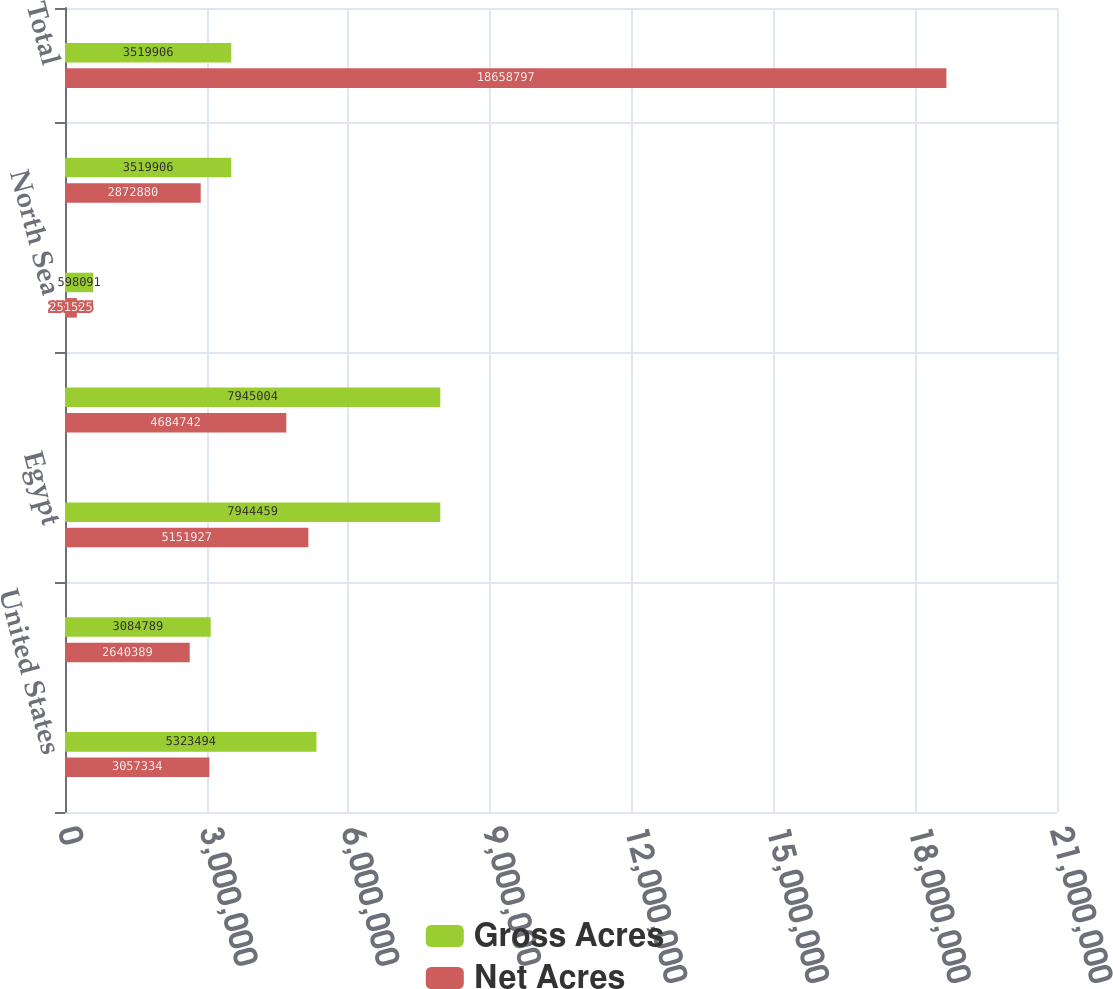<chart> <loc_0><loc_0><loc_500><loc_500><stacked_bar_chart><ecel><fcel>United States<fcel>Canada<fcel>Egypt<fcel>Australia<fcel>North Sea<fcel>Argentina<fcel>Total<nl><fcel>Gross Acres<fcel>5.32349e+06<fcel>3.08479e+06<fcel>7.94446e+06<fcel>7.945e+06<fcel>598091<fcel>3.51991e+06<fcel>3.51991e+06<nl><fcel>Net Acres<fcel>3.05733e+06<fcel>2.64039e+06<fcel>5.15193e+06<fcel>4.68474e+06<fcel>251525<fcel>2.87288e+06<fcel>1.86588e+07<nl></chart> 